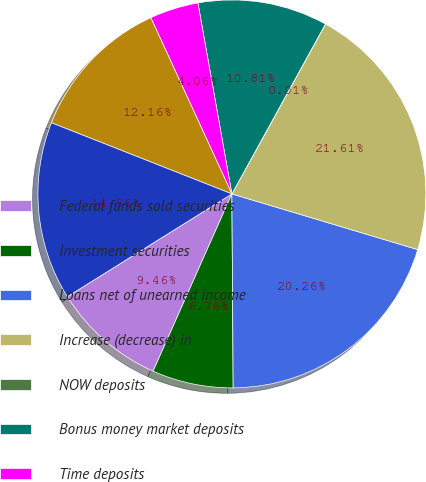<chart> <loc_0><loc_0><loc_500><loc_500><pie_chart><fcel>Federal funds sold securities<fcel>Investment securities<fcel>Loans net of unearned income<fcel>Increase (decrease) in<fcel>NOW deposits<fcel>Bonus money market deposits<fcel>Time deposits<fcel>Sweep deposits<fcel>Total increase (decrease) in<nl><fcel>9.46%<fcel>6.76%<fcel>20.26%<fcel>21.61%<fcel>0.01%<fcel>10.81%<fcel>4.06%<fcel>12.16%<fcel>14.86%<nl></chart> 